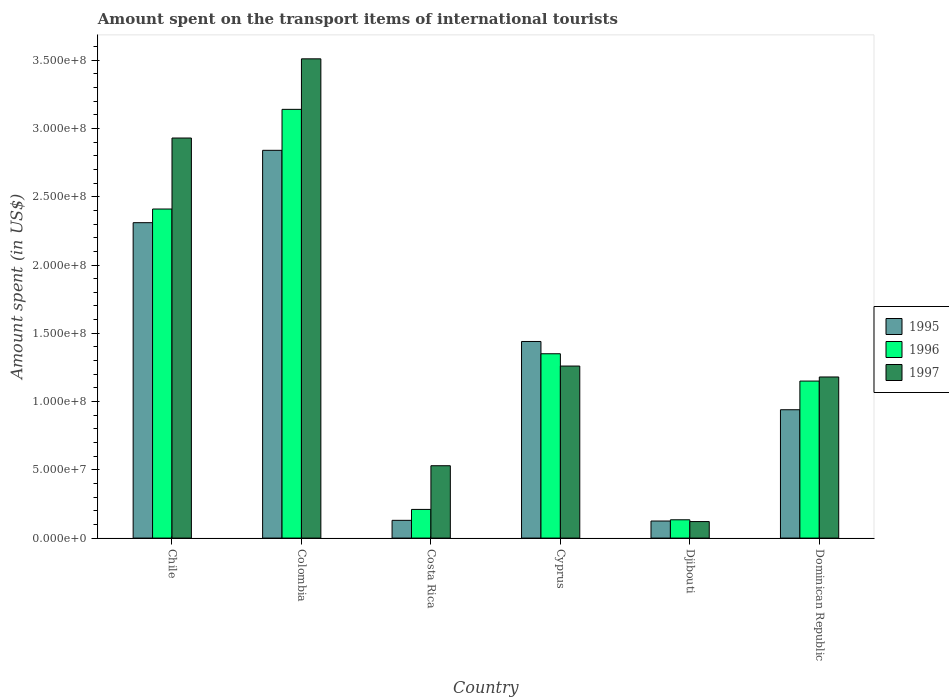How many groups of bars are there?
Keep it short and to the point. 6. Are the number of bars per tick equal to the number of legend labels?
Offer a very short reply. Yes. Are the number of bars on each tick of the X-axis equal?
Provide a succinct answer. Yes. How many bars are there on the 3rd tick from the right?
Provide a succinct answer. 3. What is the label of the 1st group of bars from the left?
Your response must be concise. Chile. In how many cases, is the number of bars for a given country not equal to the number of legend labels?
Ensure brevity in your answer.  0. What is the amount spent on the transport items of international tourists in 1995 in Colombia?
Your answer should be very brief. 2.84e+08. Across all countries, what is the maximum amount spent on the transport items of international tourists in 1996?
Provide a succinct answer. 3.14e+08. Across all countries, what is the minimum amount spent on the transport items of international tourists in 1995?
Provide a succinct answer. 1.25e+07. In which country was the amount spent on the transport items of international tourists in 1997 minimum?
Your answer should be very brief. Djibouti. What is the total amount spent on the transport items of international tourists in 1995 in the graph?
Provide a short and direct response. 7.78e+08. What is the difference between the amount spent on the transport items of international tourists in 1996 in Colombia and that in Dominican Republic?
Offer a very short reply. 1.99e+08. What is the difference between the amount spent on the transport items of international tourists in 1996 in Djibouti and the amount spent on the transport items of international tourists in 1997 in Cyprus?
Offer a terse response. -1.13e+08. What is the average amount spent on the transport items of international tourists in 1997 per country?
Provide a succinct answer. 1.59e+08. What is the difference between the amount spent on the transport items of international tourists of/in 1996 and amount spent on the transport items of international tourists of/in 1995 in Costa Rica?
Provide a short and direct response. 8.00e+06. In how many countries, is the amount spent on the transport items of international tourists in 1997 greater than 340000000 US$?
Offer a terse response. 1. What is the ratio of the amount spent on the transport items of international tourists in 1995 in Djibouti to that in Dominican Republic?
Your response must be concise. 0.13. What is the difference between the highest and the second highest amount spent on the transport items of international tourists in 1995?
Provide a short and direct response. 1.40e+08. What is the difference between the highest and the lowest amount spent on the transport items of international tourists in 1995?
Give a very brief answer. 2.72e+08. In how many countries, is the amount spent on the transport items of international tourists in 1997 greater than the average amount spent on the transport items of international tourists in 1997 taken over all countries?
Your answer should be very brief. 2. What does the 2nd bar from the left in Djibouti represents?
Offer a very short reply. 1996. How many bars are there?
Give a very brief answer. 18. Are all the bars in the graph horizontal?
Ensure brevity in your answer.  No. How many countries are there in the graph?
Make the answer very short. 6. What is the difference between two consecutive major ticks on the Y-axis?
Offer a very short reply. 5.00e+07. Where does the legend appear in the graph?
Provide a succinct answer. Center right. How many legend labels are there?
Your response must be concise. 3. What is the title of the graph?
Your answer should be compact. Amount spent on the transport items of international tourists. What is the label or title of the X-axis?
Give a very brief answer. Country. What is the label or title of the Y-axis?
Keep it short and to the point. Amount spent (in US$). What is the Amount spent (in US$) of 1995 in Chile?
Your answer should be very brief. 2.31e+08. What is the Amount spent (in US$) in 1996 in Chile?
Keep it short and to the point. 2.41e+08. What is the Amount spent (in US$) of 1997 in Chile?
Provide a succinct answer. 2.93e+08. What is the Amount spent (in US$) in 1995 in Colombia?
Make the answer very short. 2.84e+08. What is the Amount spent (in US$) in 1996 in Colombia?
Offer a very short reply. 3.14e+08. What is the Amount spent (in US$) in 1997 in Colombia?
Provide a short and direct response. 3.51e+08. What is the Amount spent (in US$) of 1995 in Costa Rica?
Make the answer very short. 1.30e+07. What is the Amount spent (in US$) in 1996 in Costa Rica?
Provide a short and direct response. 2.10e+07. What is the Amount spent (in US$) in 1997 in Costa Rica?
Provide a succinct answer. 5.30e+07. What is the Amount spent (in US$) of 1995 in Cyprus?
Keep it short and to the point. 1.44e+08. What is the Amount spent (in US$) in 1996 in Cyprus?
Give a very brief answer. 1.35e+08. What is the Amount spent (in US$) of 1997 in Cyprus?
Make the answer very short. 1.26e+08. What is the Amount spent (in US$) of 1995 in Djibouti?
Your answer should be compact. 1.25e+07. What is the Amount spent (in US$) of 1996 in Djibouti?
Offer a very short reply. 1.34e+07. What is the Amount spent (in US$) of 1997 in Djibouti?
Your answer should be compact. 1.21e+07. What is the Amount spent (in US$) in 1995 in Dominican Republic?
Provide a succinct answer. 9.40e+07. What is the Amount spent (in US$) in 1996 in Dominican Republic?
Your answer should be very brief. 1.15e+08. What is the Amount spent (in US$) of 1997 in Dominican Republic?
Make the answer very short. 1.18e+08. Across all countries, what is the maximum Amount spent (in US$) in 1995?
Your answer should be very brief. 2.84e+08. Across all countries, what is the maximum Amount spent (in US$) in 1996?
Offer a terse response. 3.14e+08. Across all countries, what is the maximum Amount spent (in US$) of 1997?
Your answer should be compact. 3.51e+08. Across all countries, what is the minimum Amount spent (in US$) in 1995?
Provide a short and direct response. 1.25e+07. Across all countries, what is the minimum Amount spent (in US$) in 1996?
Provide a succinct answer. 1.34e+07. Across all countries, what is the minimum Amount spent (in US$) in 1997?
Provide a succinct answer. 1.21e+07. What is the total Amount spent (in US$) in 1995 in the graph?
Your answer should be very brief. 7.78e+08. What is the total Amount spent (in US$) of 1996 in the graph?
Your answer should be compact. 8.39e+08. What is the total Amount spent (in US$) of 1997 in the graph?
Your response must be concise. 9.53e+08. What is the difference between the Amount spent (in US$) in 1995 in Chile and that in Colombia?
Ensure brevity in your answer.  -5.30e+07. What is the difference between the Amount spent (in US$) of 1996 in Chile and that in Colombia?
Provide a succinct answer. -7.30e+07. What is the difference between the Amount spent (in US$) in 1997 in Chile and that in Colombia?
Provide a short and direct response. -5.80e+07. What is the difference between the Amount spent (in US$) of 1995 in Chile and that in Costa Rica?
Provide a short and direct response. 2.18e+08. What is the difference between the Amount spent (in US$) of 1996 in Chile and that in Costa Rica?
Your answer should be compact. 2.20e+08. What is the difference between the Amount spent (in US$) of 1997 in Chile and that in Costa Rica?
Keep it short and to the point. 2.40e+08. What is the difference between the Amount spent (in US$) of 1995 in Chile and that in Cyprus?
Offer a terse response. 8.70e+07. What is the difference between the Amount spent (in US$) in 1996 in Chile and that in Cyprus?
Your response must be concise. 1.06e+08. What is the difference between the Amount spent (in US$) in 1997 in Chile and that in Cyprus?
Offer a very short reply. 1.67e+08. What is the difference between the Amount spent (in US$) in 1995 in Chile and that in Djibouti?
Your response must be concise. 2.18e+08. What is the difference between the Amount spent (in US$) in 1996 in Chile and that in Djibouti?
Your response must be concise. 2.28e+08. What is the difference between the Amount spent (in US$) of 1997 in Chile and that in Djibouti?
Provide a short and direct response. 2.81e+08. What is the difference between the Amount spent (in US$) of 1995 in Chile and that in Dominican Republic?
Keep it short and to the point. 1.37e+08. What is the difference between the Amount spent (in US$) of 1996 in Chile and that in Dominican Republic?
Keep it short and to the point. 1.26e+08. What is the difference between the Amount spent (in US$) of 1997 in Chile and that in Dominican Republic?
Make the answer very short. 1.75e+08. What is the difference between the Amount spent (in US$) of 1995 in Colombia and that in Costa Rica?
Your answer should be very brief. 2.71e+08. What is the difference between the Amount spent (in US$) in 1996 in Colombia and that in Costa Rica?
Your response must be concise. 2.93e+08. What is the difference between the Amount spent (in US$) in 1997 in Colombia and that in Costa Rica?
Provide a succinct answer. 2.98e+08. What is the difference between the Amount spent (in US$) in 1995 in Colombia and that in Cyprus?
Provide a succinct answer. 1.40e+08. What is the difference between the Amount spent (in US$) of 1996 in Colombia and that in Cyprus?
Offer a very short reply. 1.79e+08. What is the difference between the Amount spent (in US$) in 1997 in Colombia and that in Cyprus?
Make the answer very short. 2.25e+08. What is the difference between the Amount spent (in US$) of 1995 in Colombia and that in Djibouti?
Keep it short and to the point. 2.72e+08. What is the difference between the Amount spent (in US$) of 1996 in Colombia and that in Djibouti?
Provide a succinct answer. 3.01e+08. What is the difference between the Amount spent (in US$) of 1997 in Colombia and that in Djibouti?
Offer a very short reply. 3.39e+08. What is the difference between the Amount spent (in US$) in 1995 in Colombia and that in Dominican Republic?
Offer a terse response. 1.90e+08. What is the difference between the Amount spent (in US$) of 1996 in Colombia and that in Dominican Republic?
Make the answer very short. 1.99e+08. What is the difference between the Amount spent (in US$) of 1997 in Colombia and that in Dominican Republic?
Your answer should be compact. 2.33e+08. What is the difference between the Amount spent (in US$) of 1995 in Costa Rica and that in Cyprus?
Offer a very short reply. -1.31e+08. What is the difference between the Amount spent (in US$) of 1996 in Costa Rica and that in Cyprus?
Keep it short and to the point. -1.14e+08. What is the difference between the Amount spent (in US$) in 1997 in Costa Rica and that in Cyprus?
Make the answer very short. -7.30e+07. What is the difference between the Amount spent (in US$) in 1995 in Costa Rica and that in Djibouti?
Your answer should be very brief. 5.00e+05. What is the difference between the Amount spent (in US$) of 1996 in Costa Rica and that in Djibouti?
Offer a very short reply. 7.60e+06. What is the difference between the Amount spent (in US$) in 1997 in Costa Rica and that in Djibouti?
Your answer should be very brief. 4.09e+07. What is the difference between the Amount spent (in US$) in 1995 in Costa Rica and that in Dominican Republic?
Provide a succinct answer. -8.10e+07. What is the difference between the Amount spent (in US$) in 1996 in Costa Rica and that in Dominican Republic?
Provide a short and direct response. -9.40e+07. What is the difference between the Amount spent (in US$) of 1997 in Costa Rica and that in Dominican Republic?
Your response must be concise. -6.50e+07. What is the difference between the Amount spent (in US$) in 1995 in Cyprus and that in Djibouti?
Your answer should be compact. 1.32e+08. What is the difference between the Amount spent (in US$) of 1996 in Cyprus and that in Djibouti?
Your answer should be compact. 1.22e+08. What is the difference between the Amount spent (in US$) in 1997 in Cyprus and that in Djibouti?
Give a very brief answer. 1.14e+08. What is the difference between the Amount spent (in US$) in 1996 in Cyprus and that in Dominican Republic?
Make the answer very short. 2.00e+07. What is the difference between the Amount spent (in US$) of 1995 in Djibouti and that in Dominican Republic?
Your response must be concise. -8.15e+07. What is the difference between the Amount spent (in US$) in 1996 in Djibouti and that in Dominican Republic?
Ensure brevity in your answer.  -1.02e+08. What is the difference between the Amount spent (in US$) of 1997 in Djibouti and that in Dominican Republic?
Offer a very short reply. -1.06e+08. What is the difference between the Amount spent (in US$) in 1995 in Chile and the Amount spent (in US$) in 1996 in Colombia?
Offer a terse response. -8.30e+07. What is the difference between the Amount spent (in US$) of 1995 in Chile and the Amount spent (in US$) of 1997 in Colombia?
Your answer should be compact. -1.20e+08. What is the difference between the Amount spent (in US$) in 1996 in Chile and the Amount spent (in US$) in 1997 in Colombia?
Offer a terse response. -1.10e+08. What is the difference between the Amount spent (in US$) of 1995 in Chile and the Amount spent (in US$) of 1996 in Costa Rica?
Provide a short and direct response. 2.10e+08. What is the difference between the Amount spent (in US$) of 1995 in Chile and the Amount spent (in US$) of 1997 in Costa Rica?
Your answer should be compact. 1.78e+08. What is the difference between the Amount spent (in US$) in 1996 in Chile and the Amount spent (in US$) in 1997 in Costa Rica?
Your answer should be compact. 1.88e+08. What is the difference between the Amount spent (in US$) of 1995 in Chile and the Amount spent (in US$) of 1996 in Cyprus?
Provide a short and direct response. 9.60e+07. What is the difference between the Amount spent (in US$) of 1995 in Chile and the Amount spent (in US$) of 1997 in Cyprus?
Provide a short and direct response. 1.05e+08. What is the difference between the Amount spent (in US$) in 1996 in Chile and the Amount spent (in US$) in 1997 in Cyprus?
Ensure brevity in your answer.  1.15e+08. What is the difference between the Amount spent (in US$) of 1995 in Chile and the Amount spent (in US$) of 1996 in Djibouti?
Your response must be concise. 2.18e+08. What is the difference between the Amount spent (in US$) of 1995 in Chile and the Amount spent (in US$) of 1997 in Djibouti?
Keep it short and to the point. 2.19e+08. What is the difference between the Amount spent (in US$) of 1996 in Chile and the Amount spent (in US$) of 1997 in Djibouti?
Your response must be concise. 2.29e+08. What is the difference between the Amount spent (in US$) in 1995 in Chile and the Amount spent (in US$) in 1996 in Dominican Republic?
Provide a succinct answer. 1.16e+08. What is the difference between the Amount spent (in US$) of 1995 in Chile and the Amount spent (in US$) of 1997 in Dominican Republic?
Ensure brevity in your answer.  1.13e+08. What is the difference between the Amount spent (in US$) of 1996 in Chile and the Amount spent (in US$) of 1997 in Dominican Republic?
Ensure brevity in your answer.  1.23e+08. What is the difference between the Amount spent (in US$) of 1995 in Colombia and the Amount spent (in US$) of 1996 in Costa Rica?
Your response must be concise. 2.63e+08. What is the difference between the Amount spent (in US$) of 1995 in Colombia and the Amount spent (in US$) of 1997 in Costa Rica?
Offer a very short reply. 2.31e+08. What is the difference between the Amount spent (in US$) of 1996 in Colombia and the Amount spent (in US$) of 1997 in Costa Rica?
Give a very brief answer. 2.61e+08. What is the difference between the Amount spent (in US$) of 1995 in Colombia and the Amount spent (in US$) of 1996 in Cyprus?
Offer a very short reply. 1.49e+08. What is the difference between the Amount spent (in US$) in 1995 in Colombia and the Amount spent (in US$) in 1997 in Cyprus?
Offer a very short reply. 1.58e+08. What is the difference between the Amount spent (in US$) of 1996 in Colombia and the Amount spent (in US$) of 1997 in Cyprus?
Keep it short and to the point. 1.88e+08. What is the difference between the Amount spent (in US$) in 1995 in Colombia and the Amount spent (in US$) in 1996 in Djibouti?
Your answer should be compact. 2.71e+08. What is the difference between the Amount spent (in US$) in 1995 in Colombia and the Amount spent (in US$) in 1997 in Djibouti?
Provide a short and direct response. 2.72e+08. What is the difference between the Amount spent (in US$) in 1996 in Colombia and the Amount spent (in US$) in 1997 in Djibouti?
Provide a short and direct response. 3.02e+08. What is the difference between the Amount spent (in US$) in 1995 in Colombia and the Amount spent (in US$) in 1996 in Dominican Republic?
Make the answer very short. 1.69e+08. What is the difference between the Amount spent (in US$) of 1995 in Colombia and the Amount spent (in US$) of 1997 in Dominican Republic?
Make the answer very short. 1.66e+08. What is the difference between the Amount spent (in US$) in 1996 in Colombia and the Amount spent (in US$) in 1997 in Dominican Republic?
Your answer should be compact. 1.96e+08. What is the difference between the Amount spent (in US$) of 1995 in Costa Rica and the Amount spent (in US$) of 1996 in Cyprus?
Make the answer very short. -1.22e+08. What is the difference between the Amount spent (in US$) of 1995 in Costa Rica and the Amount spent (in US$) of 1997 in Cyprus?
Keep it short and to the point. -1.13e+08. What is the difference between the Amount spent (in US$) of 1996 in Costa Rica and the Amount spent (in US$) of 1997 in Cyprus?
Your answer should be very brief. -1.05e+08. What is the difference between the Amount spent (in US$) in 1995 in Costa Rica and the Amount spent (in US$) in 1996 in Djibouti?
Your response must be concise. -4.00e+05. What is the difference between the Amount spent (in US$) in 1995 in Costa Rica and the Amount spent (in US$) in 1997 in Djibouti?
Give a very brief answer. 9.00e+05. What is the difference between the Amount spent (in US$) of 1996 in Costa Rica and the Amount spent (in US$) of 1997 in Djibouti?
Ensure brevity in your answer.  8.90e+06. What is the difference between the Amount spent (in US$) in 1995 in Costa Rica and the Amount spent (in US$) in 1996 in Dominican Republic?
Your answer should be compact. -1.02e+08. What is the difference between the Amount spent (in US$) in 1995 in Costa Rica and the Amount spent (in US$) in 1997 in Dominican Republic?
Make the answer very short. -1.05e+08. What is the difference between the Amount spent (in US$) of 1996 in Costa Rica and the Amount spent (in US$) of 1997 in Dominican Republic?
Your response must be concise. -9.70e+07. What is the difference between the Amount spent (in US$) in 1995 in Cyprus and the Amount spent (in US$) in 1996 in Djibouti?
Offer a very short reply. 1.31e+08. What is the difference between the Amount spent (in US$) in 1995 in Cyprus and the Amount spent (in US$) in 1997 in Djibouti?
Give a very brief answer. 1.32e+08. What is the difference between the Amount spent (in US$) of 1996 in Cyprus and the Amount spent (in US$) of 1997 in Djibouti?
Make the answer very short. 1.23e+08. What is the difference between the Amount spent (in US$) in 1995 in Cyprus and the Amount spent (in US$) in 1996 in Dominican Republic?
Your answer should be compact. 2.90e+07. What is the difference between the Amount spent (in US$) in 1995 in Cyprus and the Amount spent (in US$) in 1997 in Dominican Republic?
Offer a terse response. 2.60e+07. What is the difference between the Amount spent (in US$) in 1996 in Cyprus and the Amount spent (in US$) in 1997 in Dominican Republic?
Your answer should be very brief. 1.70e+07. What is the difference between the Amount spent (in US$) of 1995 in Djibouti and the Amount spent (in US$) of 1996 in Dominican Republic?
Give a very brief answer. -1.02e+08. What is the difference between the Amount spent (in US$) in 1995 in Djibouti and the Amount spent (in US$) in 1997 in Dominican Republic?
Offer a terse response. -1.06e+08. What is the difference between the Amount spent (in US$) of 1996 in Djibouti and the Amount spent (in US$) of 1997 in Dominican Republic?
Your answer should be compact. -1.05e+08. What is the average Amount spent (in US$) in 1995 per country?
Provide a short and direct response. 1.30e+08. What is the average Amount spent (in US$) in 1996 per country?
Your answer should be compact. 1.40e+08. What is the average Amount spent (in US$) of 1997 per country?
Offer a terse response. 1.59e+08. What is the difference between the Amount spent (in US$) in 1995 and Amount spent (in US$) in 1996 in Chile?
Provide a short and direct response. -1.00e+07. What is the difference between the Amount spent (in US$) of 1995 and Amount spent (in US$) of 1997 in Chile?
Offer a very short reply. -6.20e+07. What is the difference between the Amount spent (in US$) in 1996 and Amount spent (in US$) in 1997 in Chile?
Your response must be concise. -5.20e+07. What is the difference between the Amount spent (in US$) of 1995 and Amount spent (in US$) of 1996 in Colombia?
Your answer should be very brief. -3.00e+07. What is the difference between the Amount spent (in US$) in 1995 and Amount spent (in US$) in 1997 in Colombia?
Your answer should be compact. -6.70e+07. What is the difference between the Amount spent (in US$) in 1996 and Amount spent (in US$) in 1997 in Colombia?
Give a very brief answer. -3.70e+07. What is the difference between the Amount spent (in US$) in 1995 and Amount spent (in US$) in 1996 in Costa Rica?
Provide a succinct answer. -8.00e+06. What is the difference between the Amount spent (in US$) in 1995 and Amount spent (in US$) in 1997 in Costa Rica?
Your answer should be compact. -4.00e+07. What is the difference between the Amount spent (in US$) of 1996 and Amount spent (in US$) of 1997 in Costa Rica?
Give a very brief answer. -3.20e+07. What is the difference between the Amount spent (in US$) in 1995 and Amount spent (in US$) in 1996 in Cyprus?
Make the answer very short. 9.00e+06. What is the difference between the Amount spent (in US$) of 1995 and Amount spent (in US$) of 1997 in Cyprus?
Your answer should be very brief. 1.80e+07. What is the difference between the Amount spent (in US$) in 1996 and Amount spent (in US$) in 1997 in Cyprus?
Make the answer very short. 9.00e+06. What is the difference between the Amount spent (in US$) in 1995 and Amount spent (in US$) in 1996 in Djibouti?
Offer a very short reply. -9.00e+05. What is the difference between the Amount spent (in US$) in 1996 and Amount spent (in US$) in 1997 in Djibouti?
Give a very brief answer. 1.30e+06. What is the difference between the Amount spent (in US$) of 1995 and Amount spent (in US$) of 1996 in Dominican Republic?
Provide a short and direct response. -2.10e+07. What is the difference between the Amount spent (in US$) of 1995 and Amount spent (in US$) of 1997 in Dominican Republic?
Offer a very short reply. -2.40e+07. What is the ratio of the Amount spent (in US$) of 1995 in Chile to that in Colombia?
Provide a short and direct response. 0.81. What is the ratio of the Amount spent (in US$) in 1996 in Chile to that in Colombia?
Offer a terse response. 0.77. What is the ratio of the Amount spent (in US$) in 1997 in Chile to that in Colombia?
Provide a succinct answer. 0.83. What is the ratio of the Amount spent (in US$) in 1995 in Chile to that in Costa Rica?
Your response must be concise. 17.77. What is the ratio of the Amount spent (in US$) of 1996 in Chile to that in Costa Rica?
Keep it short and to the point. 11.48. What is the ratio of the Amount spent (in US$) of 1997 in Chile to that in Costa Rica?
Provide a succinct answer. 5.53. What is the ratio of the Amount spent (in US$) of 1995 in Chile to that in Cyprus?
Offer a terse response. 1.6. What is the ratio of the Amount spent (in US$) in 1996 in Chile to that in Cyprus?
Your response must be concise. 1.79. What is the ratio of the Amount spent (in US$) in 1997 in Chile to that in Cyprus?
Ensure brevity in your answer.  2.33. What is the ratio of the Amount spent (in US$) in 1995 in Chile to that in Djibouti?
Make the answer very short. 18.48. What is the ratio of the Amount spent (in US$) of 1996 in Chile to that in Djibouti?
Offer a very short reply. 17.99. What is the ratio of the Amount spent (in US$) in 1997 in Chile to that in Djibouti?
Keep it short and to the point. 24.21. What is the ratio of the Amount spent (in US$) in 1995 in Chile to that in Dominican Republic?
Your answer should be very brief. 2.46. What is the ratio of the Amount spent (in US$) in 1996 in Chile to that in Dominican Republic?
Make the answer very short. 2.1. What is the ratio of the Amount spent (in US$) in 1997 in Chile to that in Dominican Republic?
Your answer should be compact. 2.48. What is the ratio of the Amount spent (in US$) in 1995 in Colombia to that in Costa Rica?
Offer a terse response. 21.85. What is the ratio of the Amount spent (in US$) of 1996 in Colombia to that in Costa Rica?
Your response must be concise. 14.95. What is the ratio of the Amount spent (in US$) in 1997 in Colombia to that in Costa Rica?
Give a very brief answer. 6.62. What is the ratio of the Amount spent (in US$) in 1995 in Colombia to that in Cyprus?
Make the answer very short. 1.97. What is the ratio of the Amount spent (in US$) of 1996 in Colombia to that in Cyprus?
Give a very brief answer. 2.33. What is the ratio of the Amount spent (in US$) of 1997 in Colombia to that in Cyprus?
Offer a very short reply. 2.79. What is the ratio of the Amount spent (in US$) of 1995 in Colombia to that in Djibouti?
Provide a short and direct response. 22.72. What is the ratio of the Amount spent (in US$) in 1996 in Colombia to that in Djibouti?
Offer a very short reply. 23.43. What is the ratio of the Amount spent (in US$) of 1997 in Colombia to that in Djibouti?
Provide a short and direct response. 29.01. What is the ratio of the Amount spent (in US$) in 1995 in Colombia to that in Dominican Republic?
Make the answer very short. 3.02. What is the ratio of the Amount spent (in US$) of 1996 in Colombia to that in Dominican Republic?
Give a very brief answer. 2.73. What is the ratio of the Amount spent (in US$) in 1997 in Colombia to that in Dominican Republic?
Offer a terse response. 2.97. What is the ratio of the Amount spent (in US$) in 1995 in Costa Rica to that in Cyprus?
Offer a terse response. 0.09. What is the ratio of the Amount spent (in US$) in 1996 in Costa Rica to that in Cyprus?
Your answer should be very brief. 0.16. What is the ratio of the Amount spent (in US$) of 1997 in Costa Rica to that in Cyprus?
Your answer should be compact. 0.42. What is the ratio of the Amount spent (in US$) of 1996 in Costa Rica to that in Djibouti?
Make the answer very short. 1.57. What is the ratio of the Amount spent (in US$) of 1997 in Costa Rica to that in Djibouti?
Your answer should be compact. 4.38. What is the ratio of the Amount spent (in US$) in 1995 in Costa Rica to that in Dominican Republic?
Your answer should be compact. 0.14. What is the ratio of the Amount spent (in US$) in 1996 in Costa Rica to that in Dominican Republic?
Your response must be concise. 0.18. What is the ratio of the Amount spent (in US$) of 1997 in Costa Rica to that in Dominican Republic?
Give a very brief answer. 0.45. What is the ratio of the Amount spent (in US$) of 1995 in Cyprus to that in Djibouti?
Provide a short and direct response. 11.52. What is the ratio of the Amount spent (in US$) of 1996 in Cyprus to that in Djibouti?
Give a very brief answer. 10.07. What is the ratio of the Amount spent (in US$) of 1997 in Cyprus to that in Djibouti?
Ensure brevity in your answer.  10.41. What is the ratio of the Amount spent (in US$) of 1995 in Cyprus to that in Dominican Republic?
Your answer should be very brief. 1.53. What is the ratio of the Amount spent (in US$) in 1996 in Cyprus to that in Dominican Republic?
Your answer should be compact. 1.17. What is the ratio of the Amount spent (in US$) of 1997 in Cyprus to that in Dominican Republic?
Make the answer very short. 1.07. What is the ratio of the Amount spent (in US$) in 1995 in Djibouti to that in Dominican Republic?
Offer a terse response. 0.13. What is the ratio of the Amount spent (in US$) of 1996 in Djibouti to that in Dominican Republic?
Your answer should be very brief. 0.12. What is the ratio of the Amount spent (in US$) in 1997 in Djibouti to that in Dominican Republic?
Offer a very short reply. 0.1. What is the difference between the highest and the second highest Amount spent (in US$) in 1995?
Make the answer very short. 5.30e+07. What is the difference between the highest and the second highest Amount spent (in US$) in 1996?
Offer a terse response. 7.30e+07. What is the difference between the highest and the second highest Amount spent (in US$) of 1997?
Make the answer very short. 5.80e+07. What is the difference between the highest and the lowest Amount spent (in US$) of 1995?
Ensure brevity in your answer.  2.72e+08. What is the difference between the highest and the lowest Amount spent (in US$) of 1996?
Offer a terse response. 3.01e+08. What is the difference between the highest and the lowest Amount spent (in US$) in 1997?
Your response must be concise. 3.39e+08. 